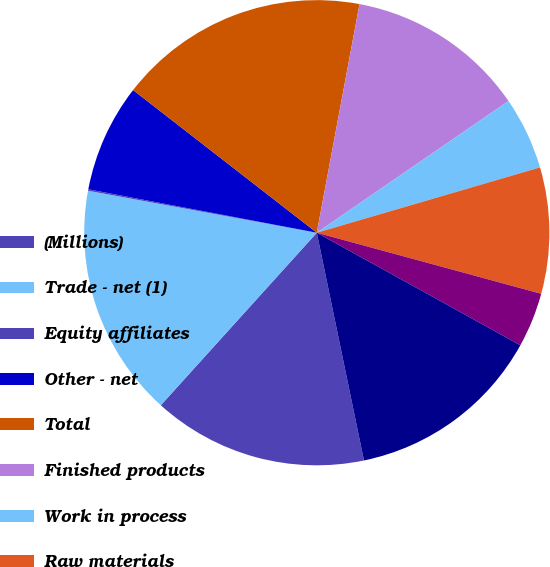Convert chart to OTSL. <chart><loc_0><loc_0><loc_500><loc_500><pie_chart><fcel>(Millions)<fcel>Trade - net (1)<fcel>Equity affiliates<fcel>Other - net<fcel>Total<fcel>Finished products<fcel>Work in process<fcel>Raw materials<fcel>Supplies<fcel>Trade<nl><fcel>14.95%<fcel>16.19%<fcel>0.1%<fcel>7.52%<fcel>17.43%<fcel>12.48%<fcel>5.05%<fcel>8.76%<fcel>3.81%<fcel>13.71%<nl></chart> 